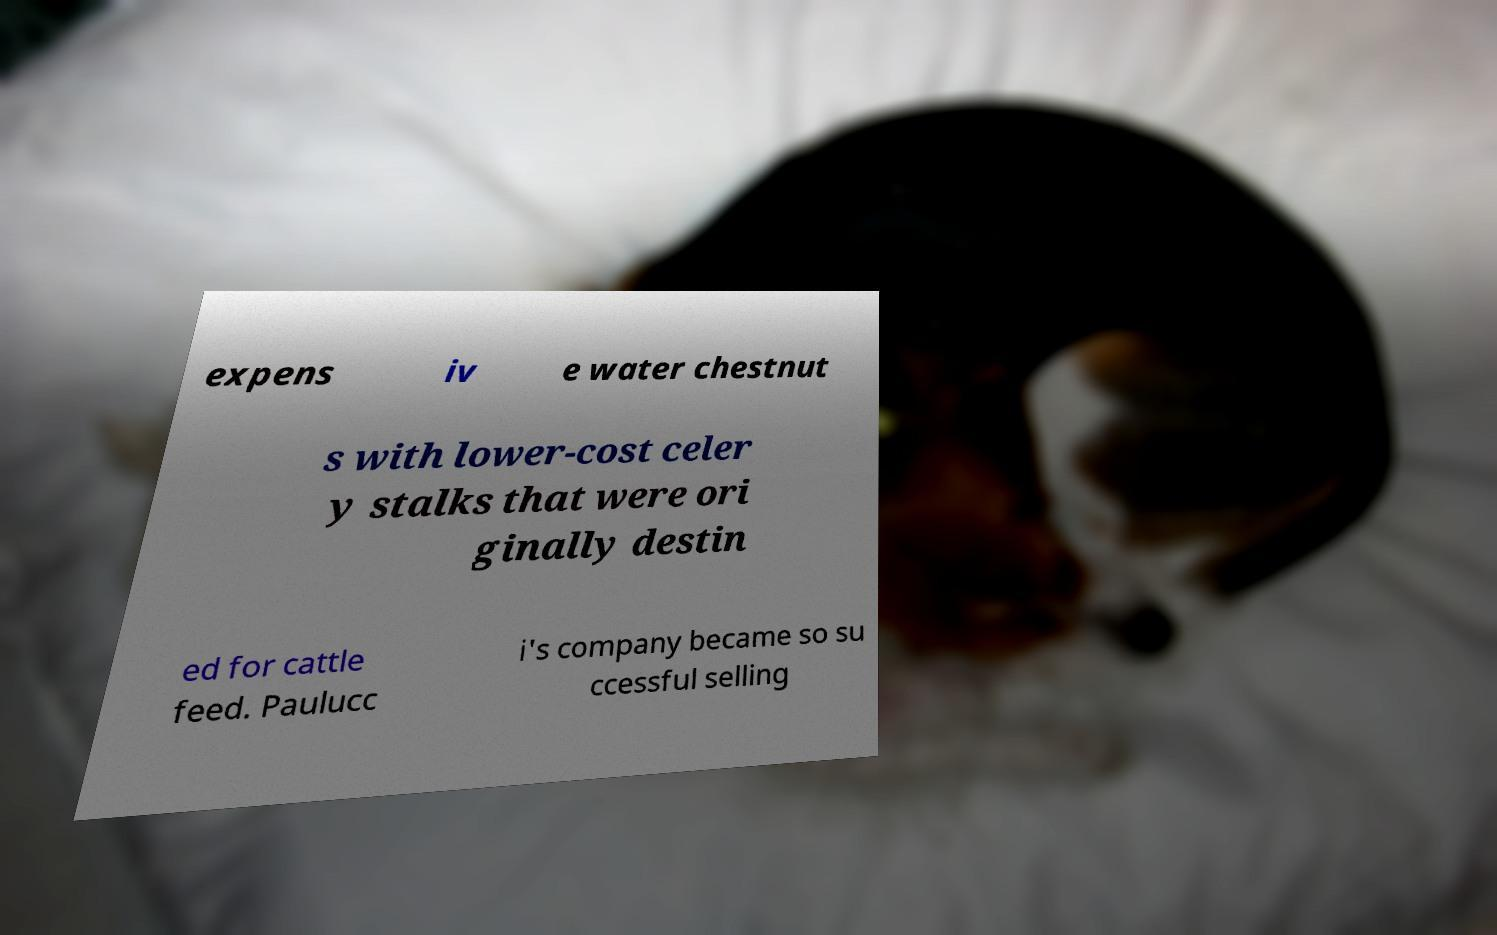Can you read and provide the text displayed in the image?This photo seems to have some interesting text. Can you extract and type it out for me? expens iv e water chestnut s with lower-cost celer y stalks that were ori ginally destin ed for cattle feed. Paulucc i's company became so su ccessful selling 